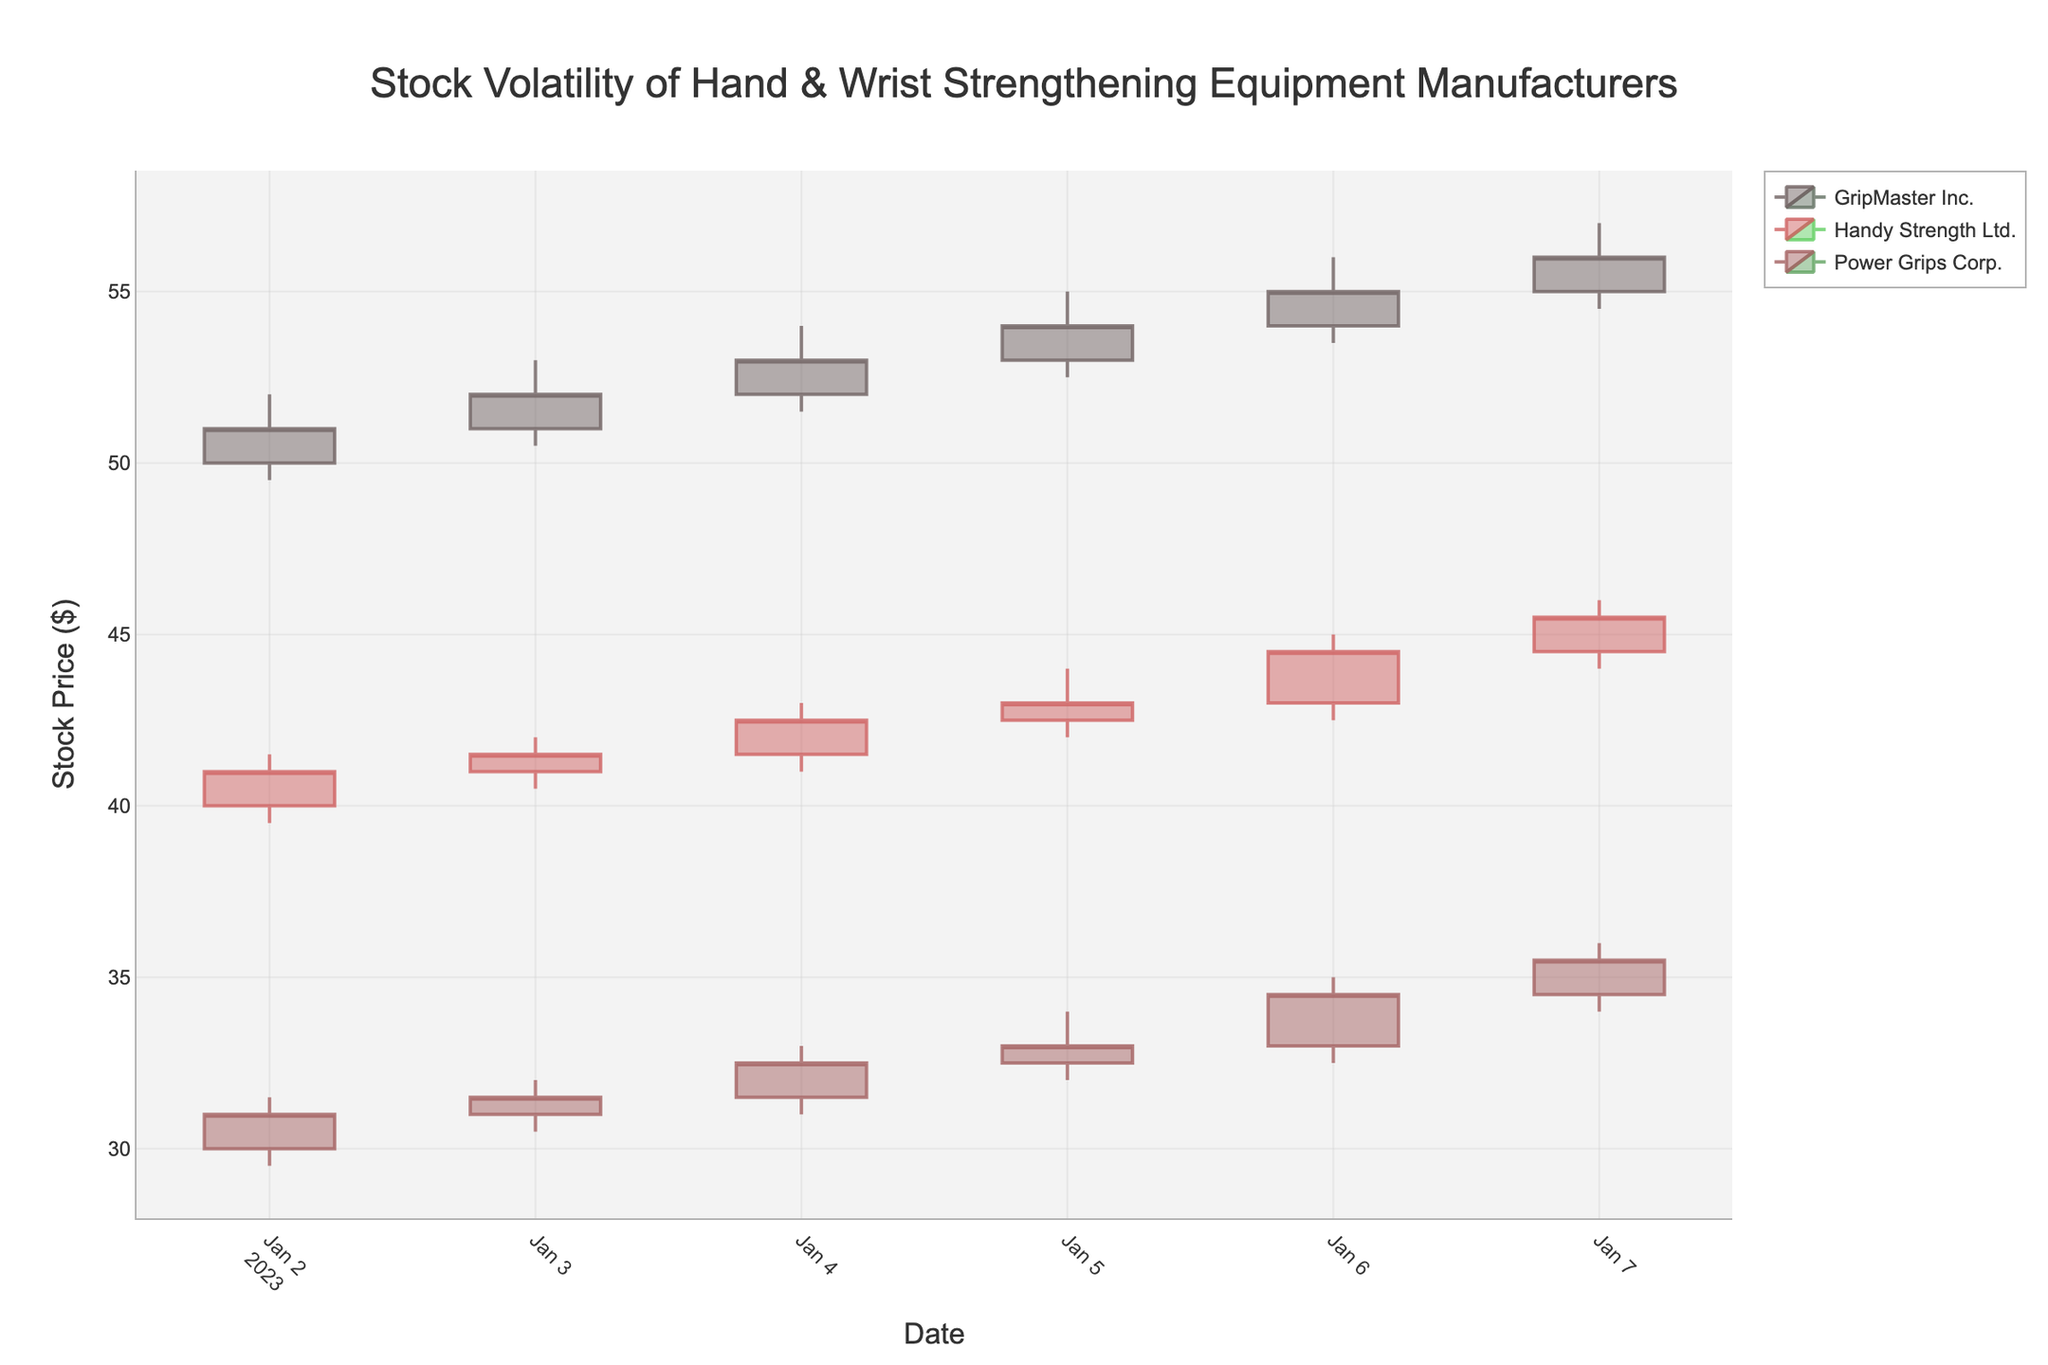What is the title of the figure? The title is located at the top-center of the chart and usually describes what the chart is about. Here, the title is "Stock Volatility of Hand & Wrist Strengthening Equipment Manufacturers."
Answer: Stock Volatility of Hand & Wrist Strengthening Equipment Manufacturers Which company has the highest closing price on January 7, 2023? To determine the highest closing price on January 7, 2023, we compare the closing prices of all companies on that date. For January 7, 2023: GripMaster Inc. closes at $56.00, Handy Strength Ltd. closes at $45.50, and Power Grips Corp. closes at $35.50.
Answer: GripMaster Inc What is the average closing price for Handy Strength Ltd. from January 2 to January 7, 2023? We sum the closing prices of Handy Strength Ltd. from January 2 to January 7, 2023, and then divide by the number of days (6). The prices are $41.00, $41.50, $42.50, $43.00, $44.50, and $45.50. Sum = 258. Dividing by 6, the average is 258/6.
Answer: $43.00 How much does the closing price for Power Grips Corp. increase from January 2 to January 7, 2023? We look at the close prices on January 2, 2023 ($31.00), and January 7, 2023 ($35.50). The increase is $35.50 - $31.00.
Answer: $4.50 Between GripMaster Inc. and Handy Strength Ltd., which company has a more significant increase in closing price from January 2 to January 7, 2023? We calculate the increase for each company over the period. GripMaster Inc.'s increase: $56.00 - $51.00 = $5.00. Handy Strength Ltd.'s increase: $45.50 - $41.00 = $4.50. Hence, GripMaster Inc. has a more significant increase.
Answer: GripMaster Inc Which company has the least volatile stock prices for the week shown in the chart? Volatility can be assessed by the range of stock prices (difference between the highest high and lowest low) during the period. Calculate this range for each company. GripMaster Inc.: $56.00 - $49.50 = $6.50, Handy Strength Ltd.: $46.00 - $39.50 = $6.50, Power Grips Corp.: $36.00 - $29.50 = $6.50. All companies have equal volatility in terms of range.
Answer: All companies have equal volatility What is the highest single-day trading volume for any company within the given week? To find the highest trading volume, we look at the 'Volume' column for each company from January 2 to January 7, 2023. The maximum values are: GripMaster Inc. (180000 on January 3), Handy Strength Ltd. (145000 on January 7), Power Grips Corp. (105000 on January 7). The highest among these is 180000 for GripMaster Inc.
Answer: 180000 Which company has the highest closing price on January 5, 2023? To determine the highest closing price on January 5, 2023, we compare the closing prices for all companies on that date. For January 5, 2023: GripMaster Inc. ($54.00), Handy Strength Ltd. ($43.00), Power Grips Corp. ($33.00).
Answer: GripMaster Inc How much does Handy Strength Ltd.'s stock price increase from its opening price on January 2, 2023, to its closing price on January 7, 2023? The opening price on January 2, 2023, is $40.00 and the closing price on January 7, 2023, is $45.50. The increase in stock price is $45.50 - $40.00.
Answer: $5.50 